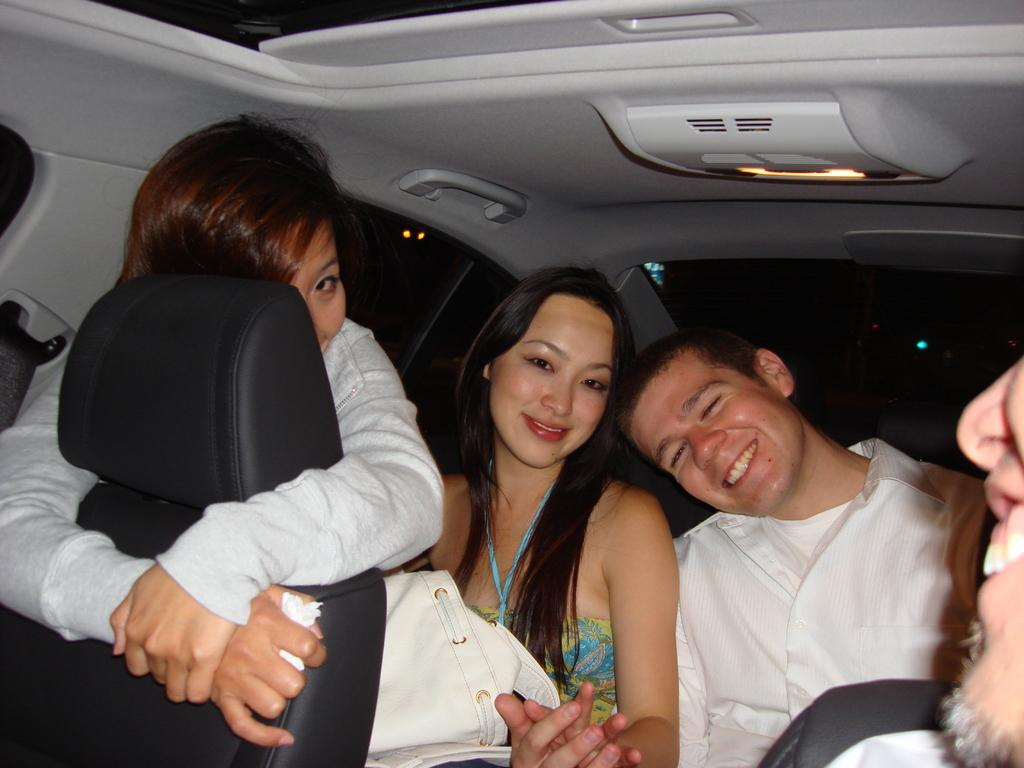How many people are present in the image? There are two people in the image, a man and a woman. What are the man and woman doing in the image? Both the man and woman are sitting inside a car. Can you describe the actions of one of the persons in the image? One of the persons is touching a seat. What type of quicksand can be seen in the image? There is no quicksand present in the image; it features a man and a woman sitting inside a car. 